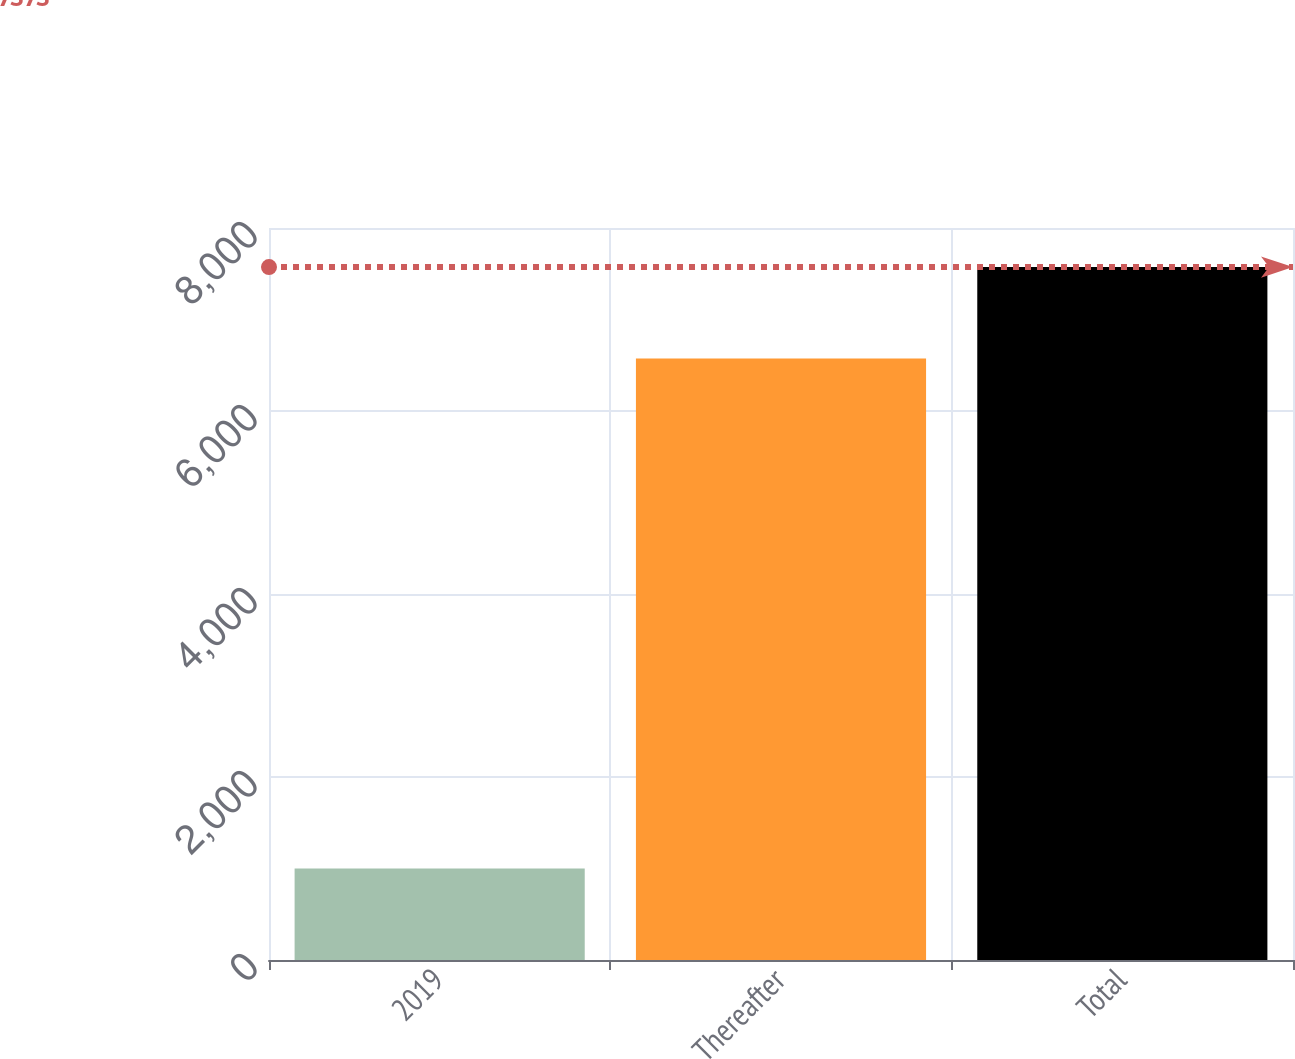Convert chart. <chart><loc_0><loc_0><loc_500><loc_500><bar_chart><fcel>2019<fcel>Thereafter<fcel>Total<nl><fcel>1000<fcel>6573<fcel>7573<nl></chart> 